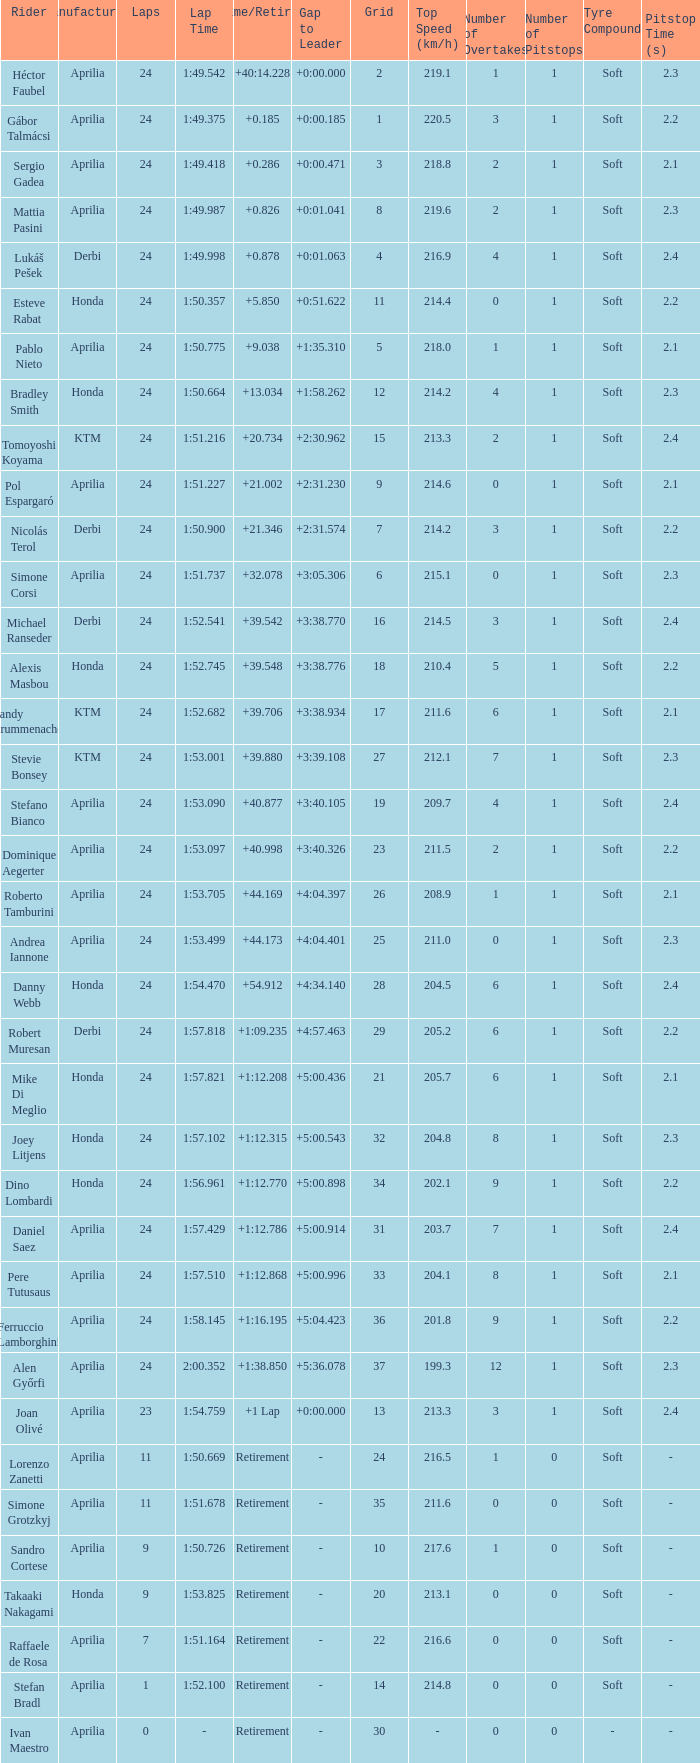What is the time with 10 grids? Retirement. 